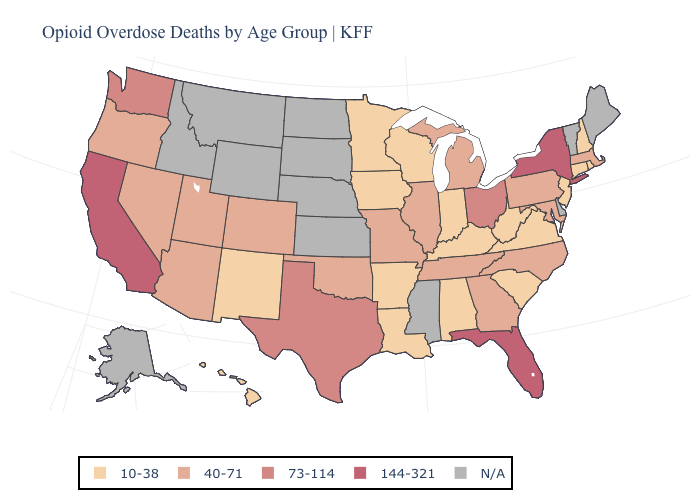Does the first symbol in the legend represent the smallest category?
Short answer required. Yes. What is the value of Maryland?
Quick response, please. 40-71. Does the map have missing data?
Quick response, please. Yes. What is the value of New Mexico?
Quick response, please. 10-38. Name the states that have a value in the range N/A?
Give a very brief answer. Alaska, Delaware, Idaho, Kansas, Maine, Mississippi, Montana, Nebraska, North Dakota, South Dakota, Vermont, Wyoming. Name the states that have a value in the range 10-38?
Keep it brief. Alabama, Arkansas, Connecticut, Hawaii, Indiana, Iowa, Kentucky, Louisiana, Minnesota, New Hampshire, New Jersey, New Mexico, Rhode Island, South Carolina, Virginia, West Virginia, Wisconsin. Which states hav the highest value in the West?
Keep it brief. California. What is the value of Utah?
Concise answer only. 40-71. Which states hav the highest value in the Northeast?
Quick response, please. New York. Name the states that have a value in the range N/A?
Answer briefly. Alaska, Delaware, Idaho, Kansas, Maine, Mississippi, Montana, Nebraska, North Dakota, South Dakota, Vermont, Wyoming. Which states have the lowest value in the USA?
Give a very brief answer. Alabama, Arkansas, Connecticut, Hawaii, Indiana, Iowa, Kentucky, Louisiana, Minnesota, New Hampshire, New Jersey, New Mexico, Rhode Island, South Carolina, Virginia, West Virginia, Wisconsin. Name the states that have a value in the range 144-321?
Give a very brief answer. California, Florida, New York. Which states have the lowest value in the USA?
Answer briefly. Alabama, Arkansas, Connecticut, Hawaii, Indiana, Iowa, Kentucky, Louisiana, Minnesota, New Hampshire, New Jersey, New Mexico, Rhode Island, South Carolina, Virginia, West Virginia, Wisconsin. 